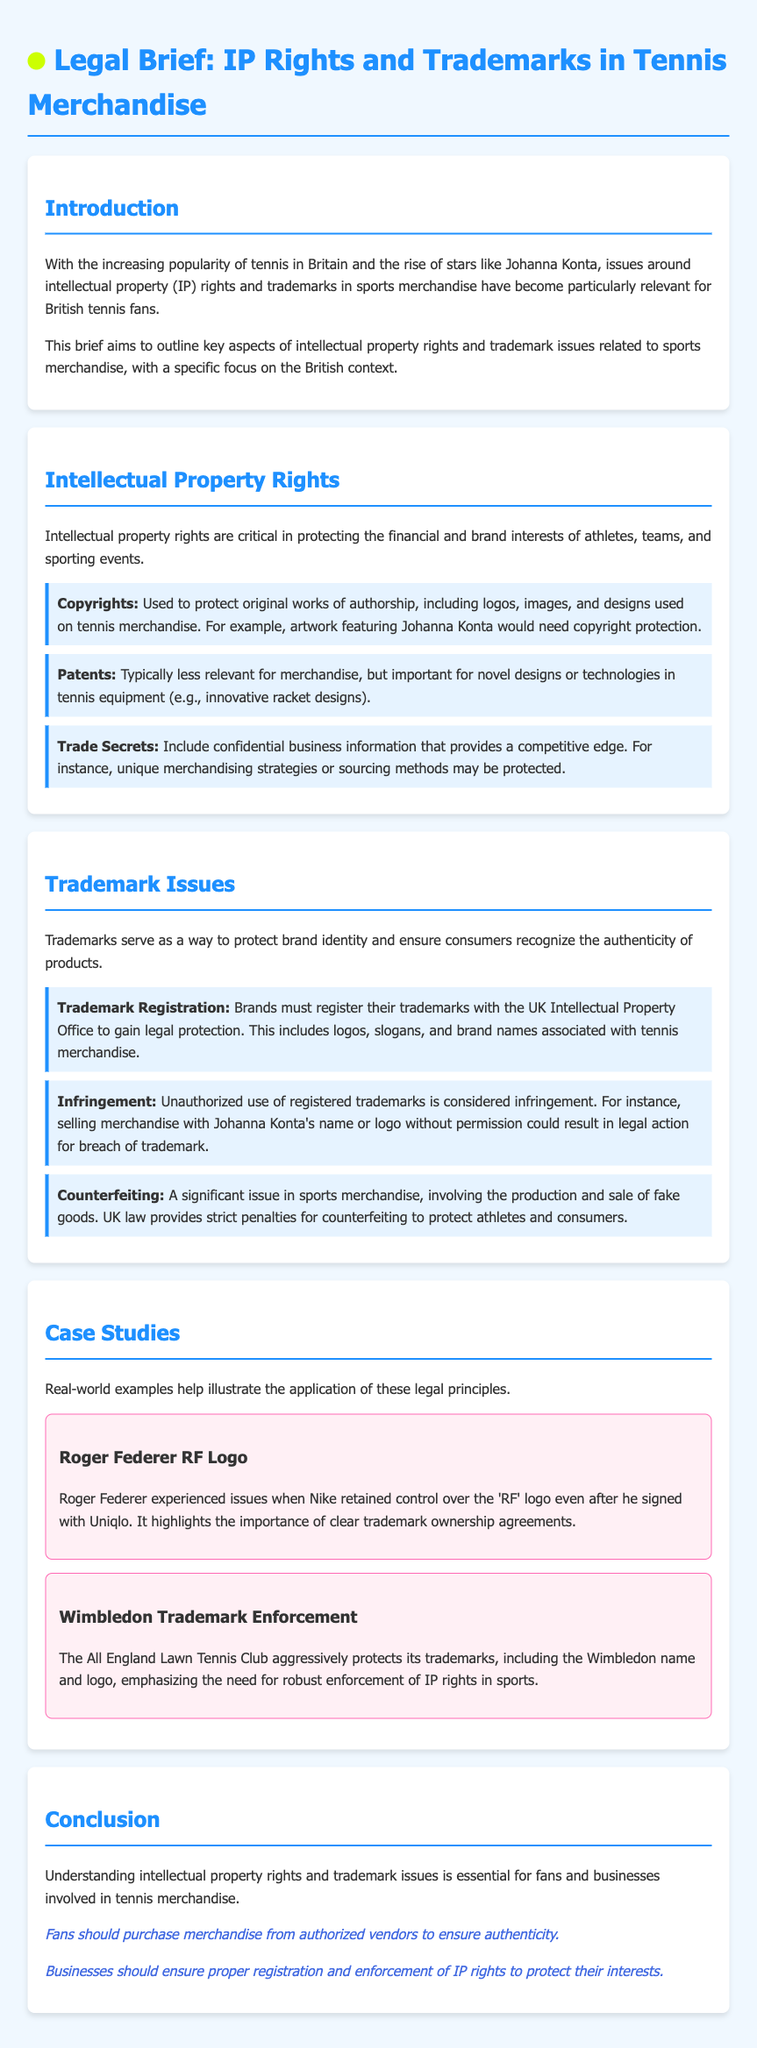What is the primary focus of this brief? The brief aims to outline key aspects of intellectual property rights and trademark issues related to sports merchandise, specifically in the British context.
Answer: Intellectual property rights and trademark issues in sports merchandise What must brands do to gain legal protection for their trademarks? Brands must register their trademarks with the UK Intellectual Property Office to gain legal protection.
Answer: Register with the UK Intellectual Property Office What is a potential consequence of unauthorized use of registered trademarks? Unauthorized use of registered trademarks is considered infringement, which may lead to legal action for breach of trademark.
Answer: Infringement Name a type of intellectual property right that protects logos. Copyrights are used to protect original works of authorship, including logos, images, and designs.
Answer: Copyrights What type of legal action is taken against counterfeiting in the UK? UK law provides strict penalties for counterfeiting to protect athletes and consumers.
Answer: Strict penalties What does the case study about Roger Federer highlight? The case highlights the importance of clear trademark ownership agreements in sports merchandise.
Answer: Clear trademark ownership agreements Who aggressively protects its trademarks according to the document? The All England Lawn Tennis Club aggressively protects its trademarks.
Answer: The All England Lawn Tennis Club What is a recommended practice for fans purchasing tennis merchandise? Fans should purchase merchandise from authorized vendors to ensure authenticity.
Answer: Purchase from authorized vendors What are trade secrets related to in the context of this document? Trade secrets include confidential business information that provides a competitive edge, like unique merchandising strategies or sourcing methods.
Answer: Confidential business information 